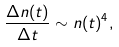Convert formula to latex. <formula><loc_0><loc_0><loc_500><loc_500>\frac { \Delta n ( t ) } { \Delta t } \sim n ( t ) ^ { 4 } ,</formula> 